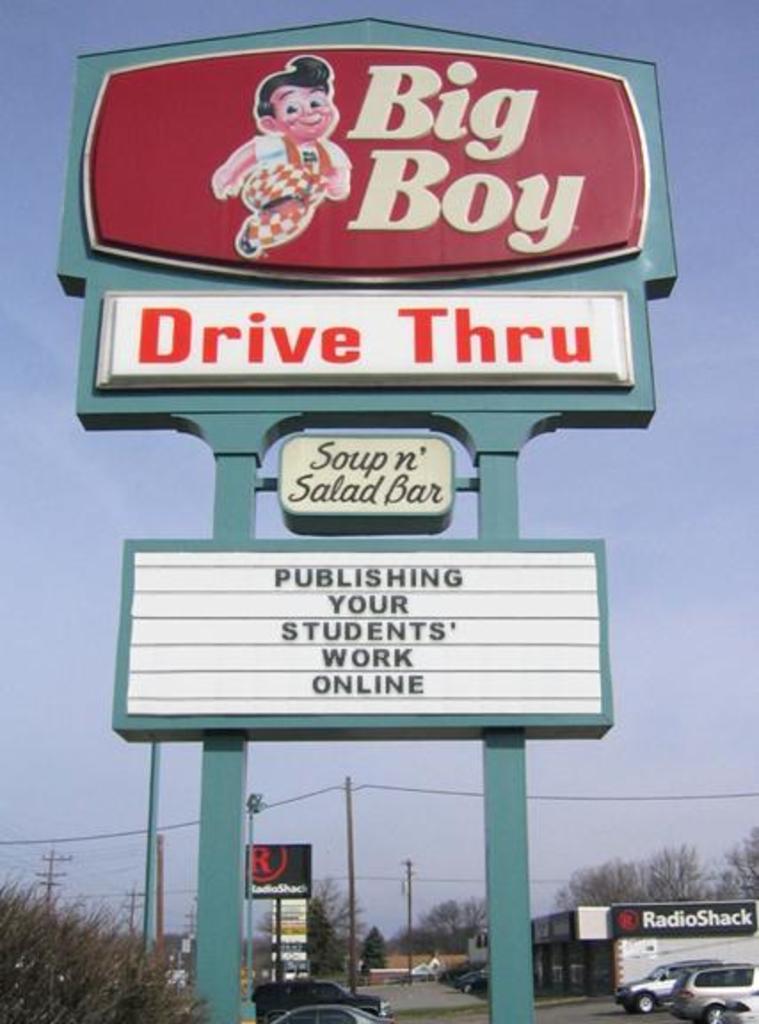Can you describe this image briefly? In this image we can see a board with text and image, there are few cars parked on the road and there are few trees, a building with text and few poles with wire and sky in the background. 